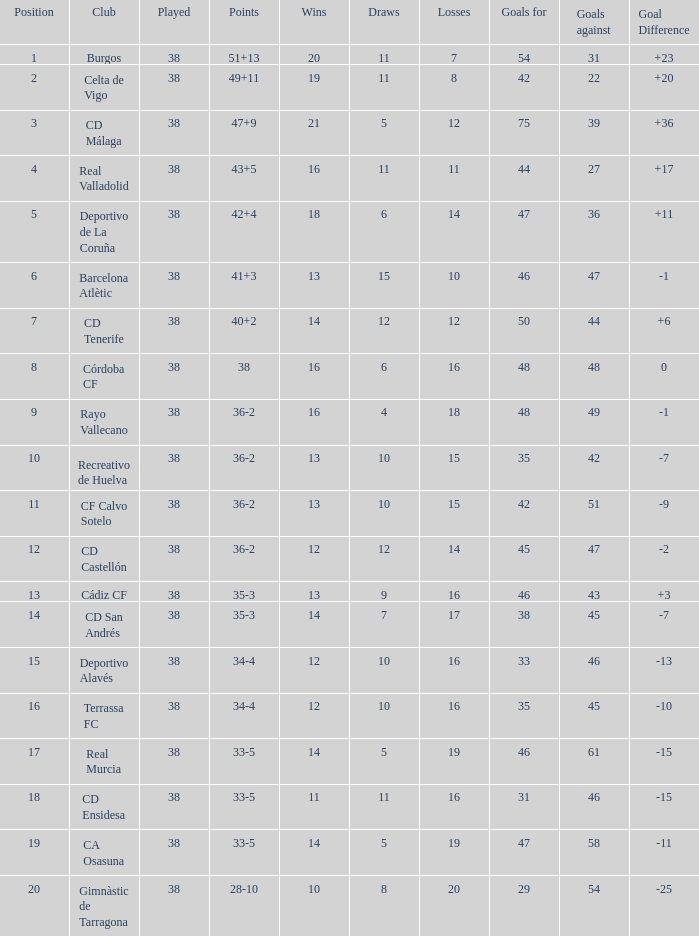What is the highest placement for a team with under 54 goals, 7 defeats, and a goal difference of more than 23? None. 